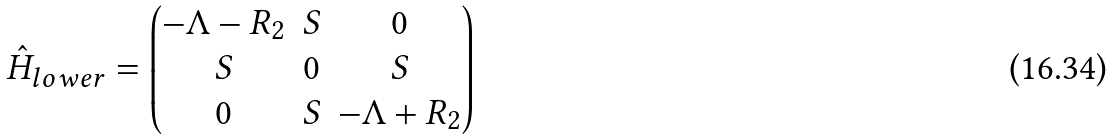Convert formula to latex. <formula><loc_0><loc_0><loc_500><loc_500>\hat { H } _ { l o w e r } = \begin{pmatrix} - \Lambda - R _ { 2 } & S & 0 \\ S & 0 & S \\ 0 & S & - \Lambda + R _ { 2 } \\ \end{pmatrix}</formula> 